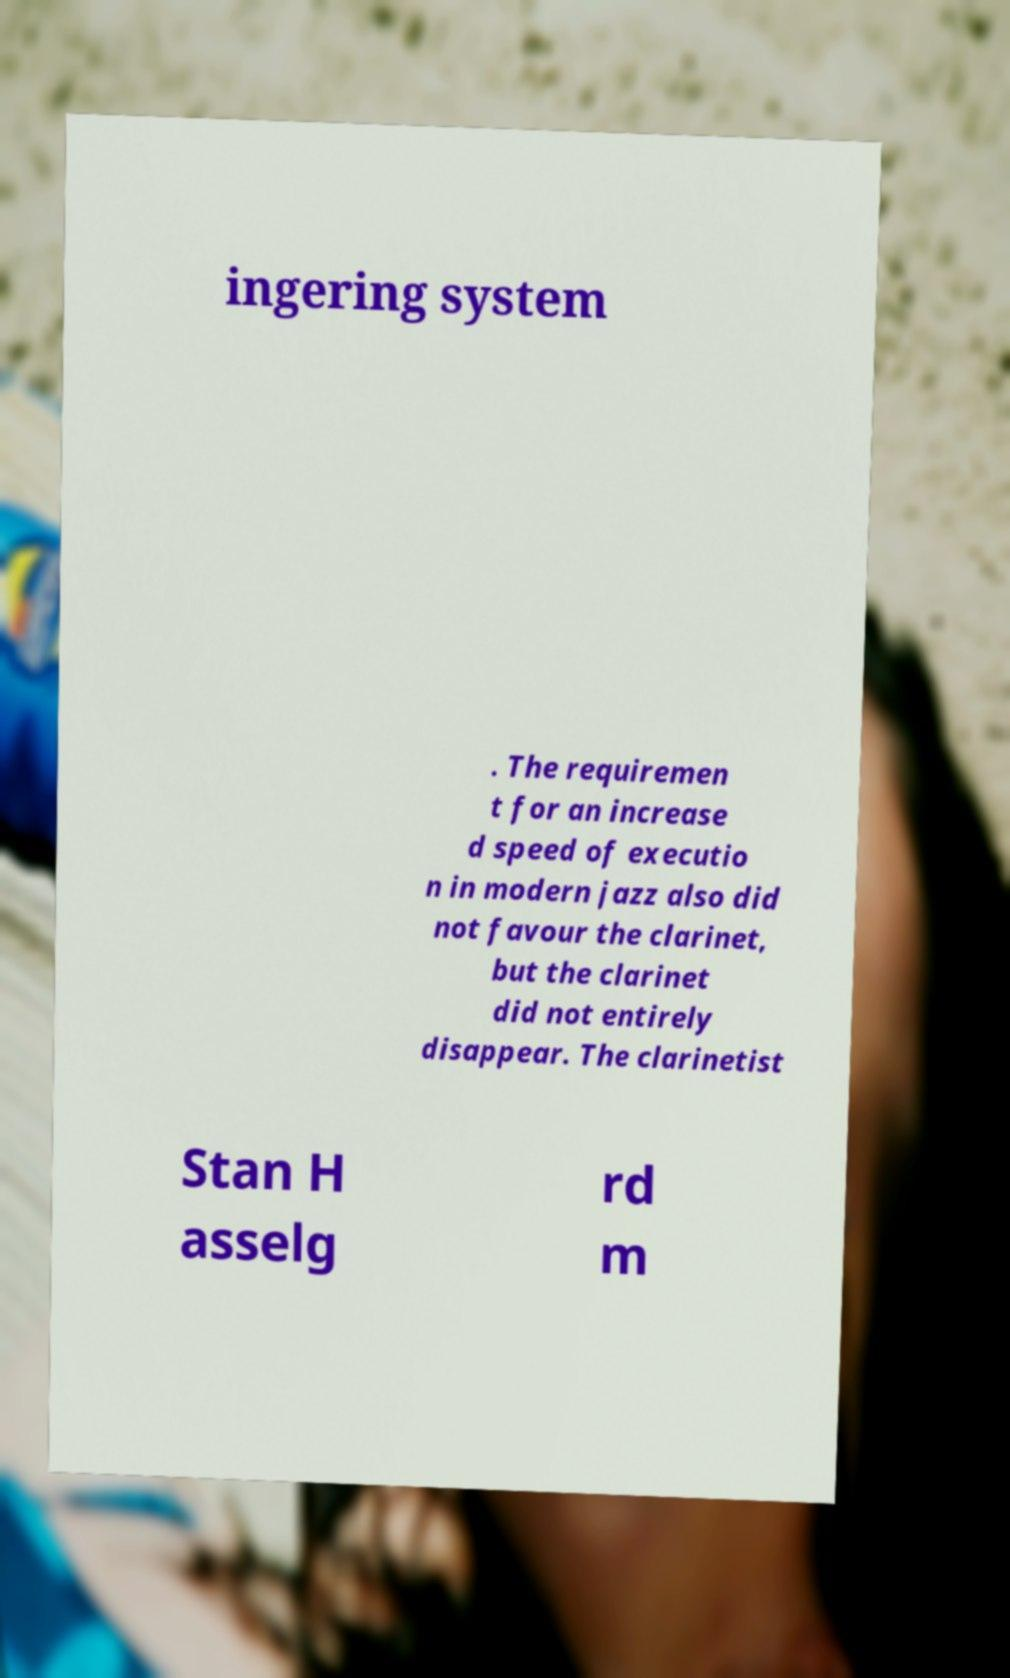Can you read and provide the text displayed in the image?This photo seems to have some interesting text. Can you extract and type it out for me? ingering system . The requiremen t for an increase d speed of executio n in modern jazz also did not favour the clarinet, but the clarinet did not entirely disappear. The clarinetist Stan H asselg rd m 